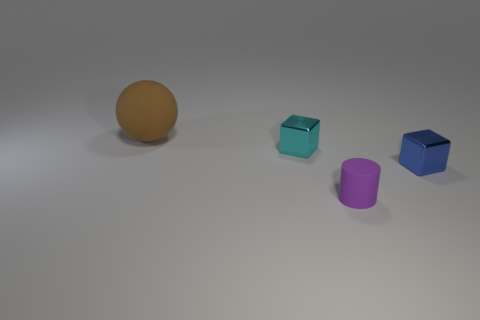Add 3 small purple rubber things. How many objects exist? 7 Subtract all spheres. How many objects are left? 3 Subtract all large brown matte balls. Subtract all purple things. How many objects are left? 2 Add 4 brown spheres. How many brown spheres are left? 5 Add 4 small purple cylinders. How many small purple cylinders exist? 5 Subtract 0 yellow balls. How many objects are left? 4 